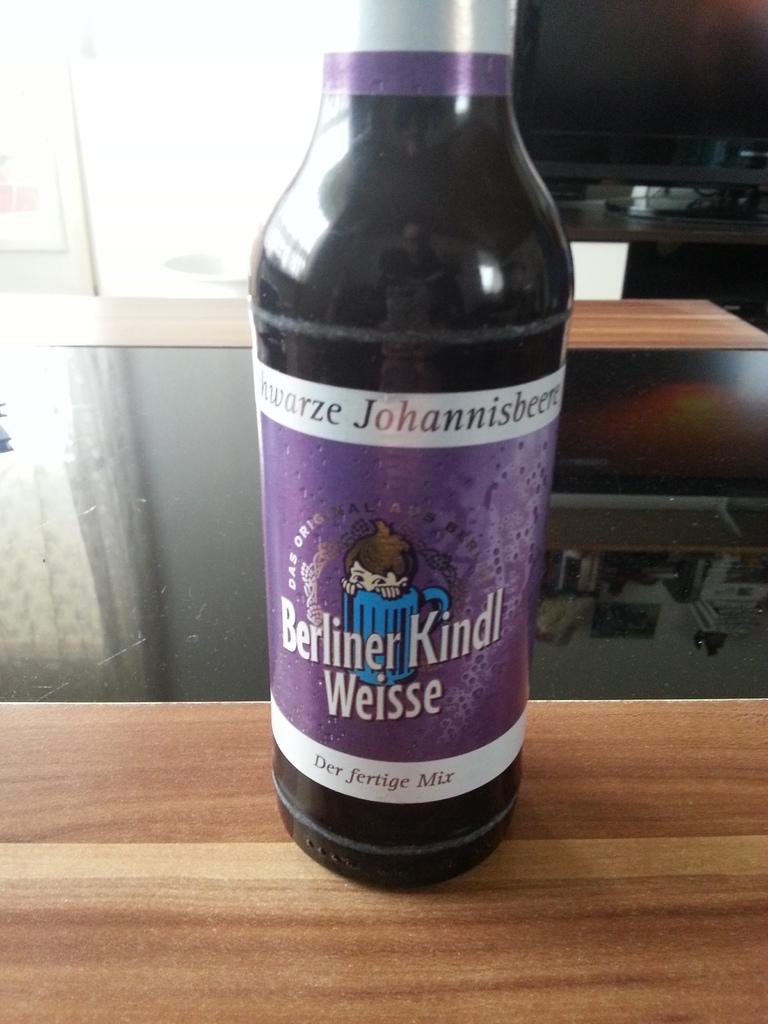Provide a one-sentence caption for the provided image. Purple bottle of drink with the name, Berliner Kindl Weisse on the label. 